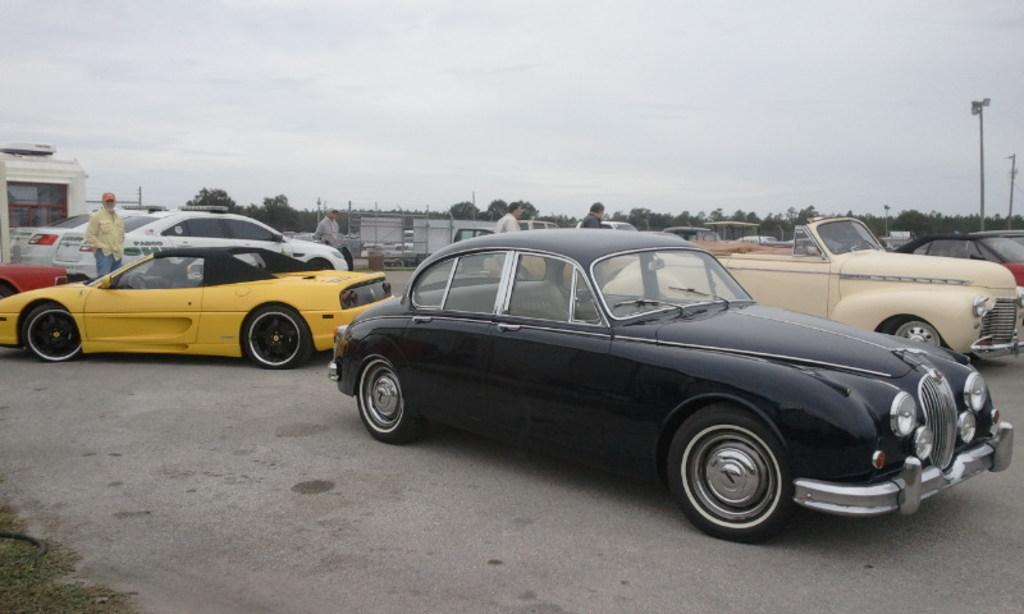What is located in the center of the image? There are cars and people in the center of the image. What can be seen in the background of the image? There are trees and poles in the background of the image. How many snails can be seen on the cars in the image? There are no snails visible on the cars in the image. What type of vacation is being taken by the people in the image? There is no indication of a vacation in the image; it simply shows cars and people in the center and trees and poles in the background. 